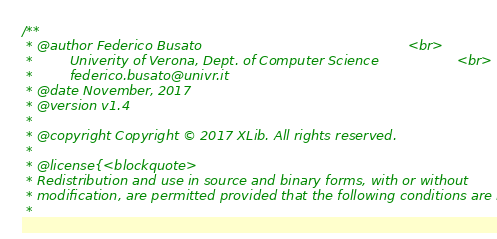<code> <loc_0><loc_0><loc_500><loc_500><_Cuda_>/**
 * @author Federico Busato                                                  <br>
 *         Univerity of Verona, Dept. of Computer Science                   <br>
 *         federico.busato@univr.it
 * @date November, 2017
 * @version v1.4
 *
 * @copyright Copyright © 2017 XLib. All rights reserved.
 *
 * @license{<blockquote>
 * Redistribution and use in source and binary forms, with or without
 * modification, are permitted provided that the following conditions are met:
 *</code> 